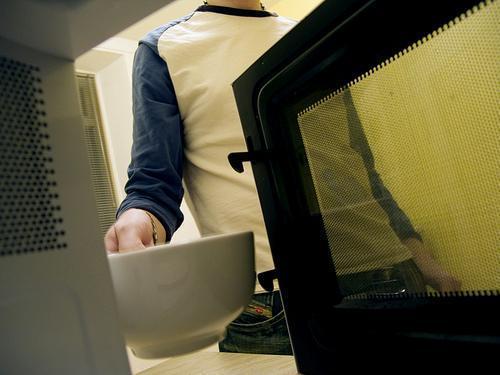How many slices of pizza are there?
Give a very brief answer. 0. 